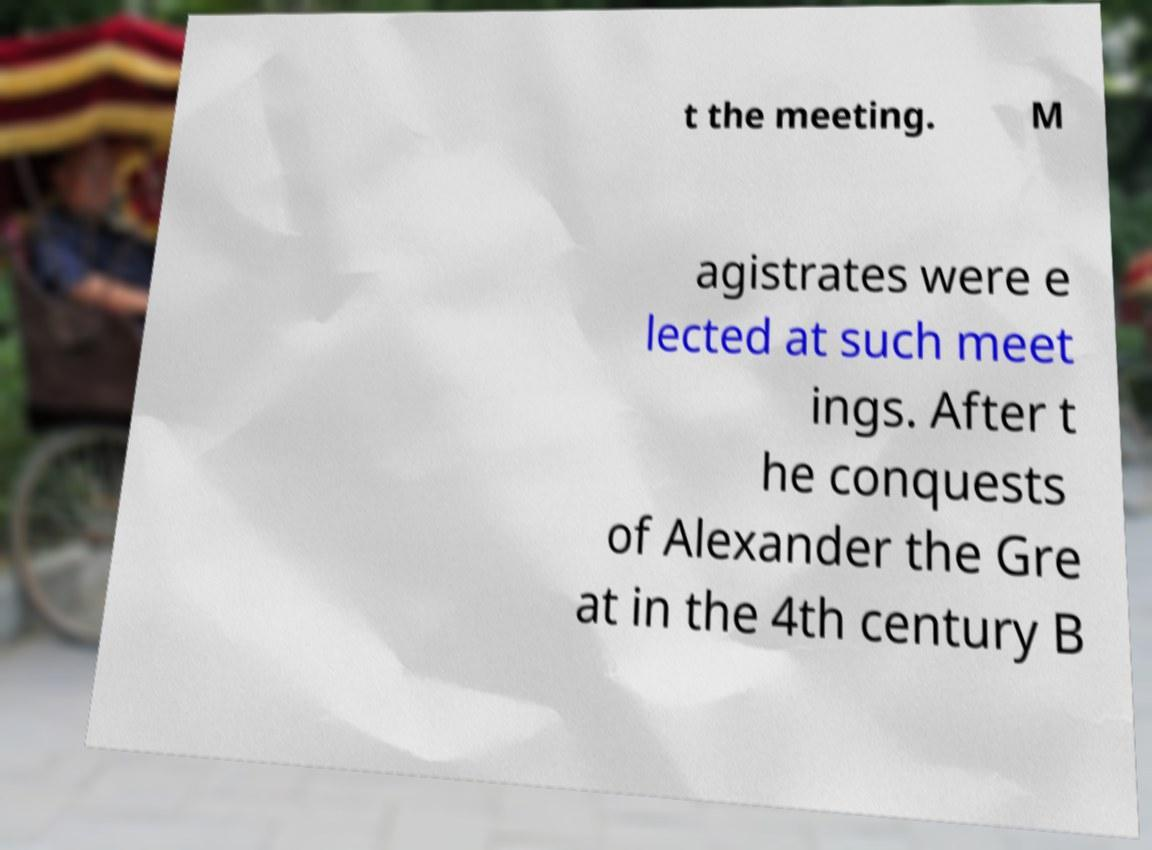There's text embedded in this image that I need extracted. Can you transcribe it verbatim? t the meeting. M agistrates were e lected at such meet ings. After t he conquests of Alexander the Gre at in the 4th century B 